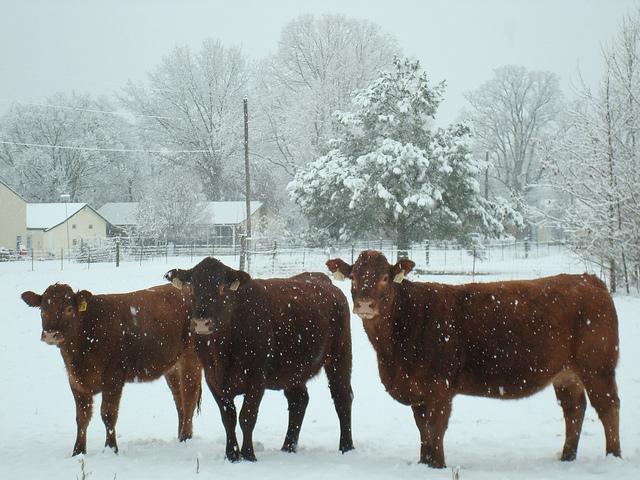What number of cow ears are in this image?
Be succinct. 6. How many animals are there?
Quick response, please. 3. Are these animals grazing?
Quick response, please. No. 